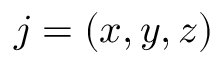Convert formula to latex. <formula><loc_0><loc_0><loc_500><loc_500>j = ( x , y , z )</formula> 